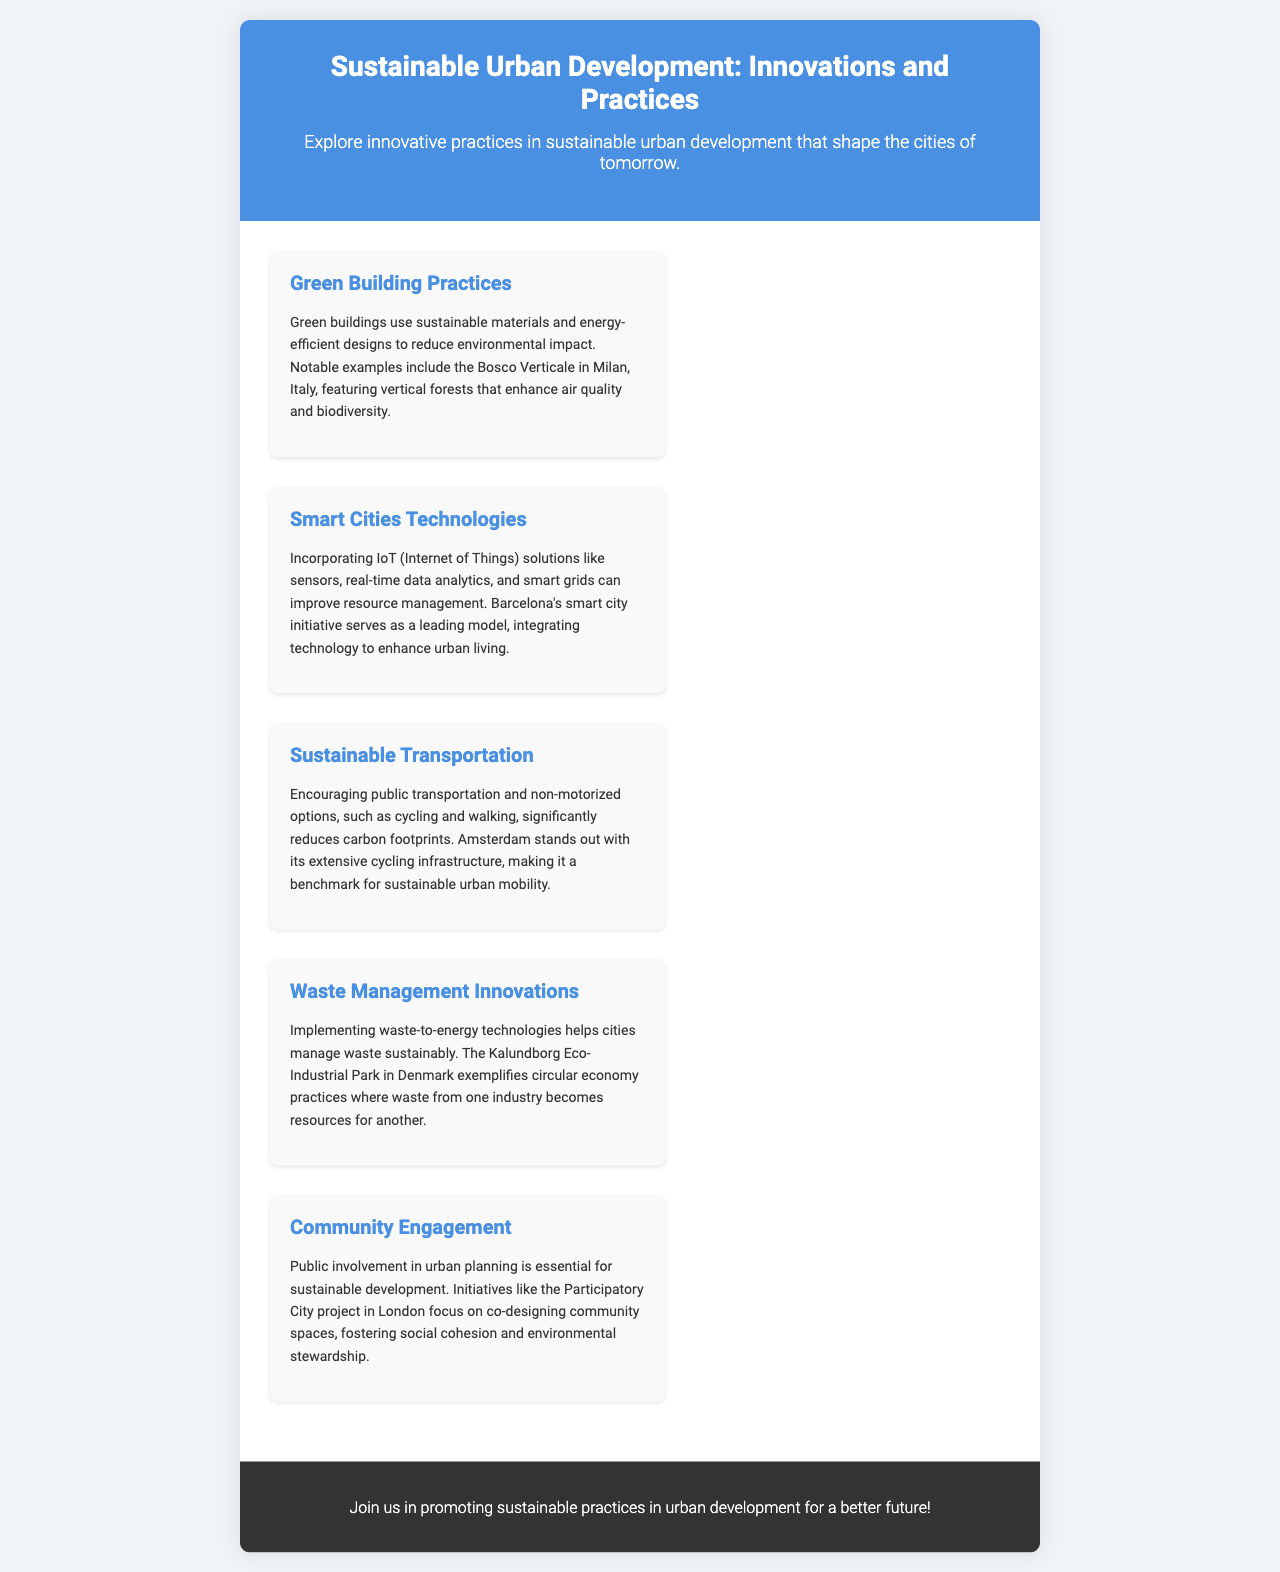what is the title of the brochure? The title of the brochure is found in the header section, which introduces the main topic.
Answer: Sustainable Urban Development: Innovations and Practices what innovative building feature is mentioned in Milan? The innovative feature is highlighted in the section about Green Building Practices.
Answer: vertical forests which city is cited as a model for smart city technology? The city recognized for its smart city initiative is mentioned in the Smart Cities Technologies section.
Answer: Barcelona what is a key feature of sustainable transportation highlighted in the document? The feature is noted in the Sustainable Transportation section, discussing options for reducing carbon footprints.
Answer: public transportation what eco-innovation is exemplified by the Kalundborg Eco-Industrial Park? The eco-innovation is discussed in the context of Waste Management Innovations section.
Answer: circular economy practices which project in London focuses on community engagement? The project is mentioned in relation to Community Engagement initiatives in the brochure.
Answer: Participatory City how many main sections are there in the brochure? The main sections are enumerated as individual content areas within the brochure.
Answer: five what color is used in the header of the brochure? The color in the header is presented in the styling section of the document.
Answer: blue 